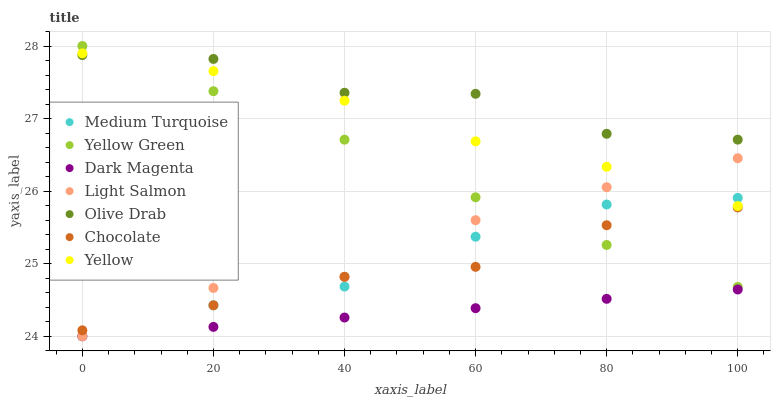Does Dark Magenta have the minimum area under the curve?
Answer yes or no. Yes. Does Olive Drab have the maximum area under the curve?
Answer yes or no. Yes. Does Yellow Green have the minimum area under the curve?
Answer yes or no. No. Does Yellow Green have the maximum area under the curve?
Answer yes or no. No. Is Dark Magenta the smoothest?
Answer yes or no. Yes. Is Olive Drab the roughest?
Answer yes or no. Yes. Is Yellow Green the smoothest?
Answer yes or no. No. Is Yellow Green the roughest?
Answer yes or no. No. Does Light Salmon have the lowest value?
Answer yes or no. Yes. Does Yellow Green have the lowest value?
Answer yes or no. No. Does Yellow Green have the highest value?
Answer yes or no. Yes. Does Yellow have the highest value?
Answer yes or no. No. Is Light Salmon less than Olive Drab?
Answer yes or no. Yes. Is Yellow Green greater than Dark Magenta?
Answer yes or no. Yes. Does Medium Turquoise intersect Light Salmon?
Answer yes or no. Yes. Is Medium Turquoise less than Light Salmon?
Answer yes or no. No. Is Medium Turquoise greater than Light Salmon?
Answer yes or no. No. Does Light Salmon intersect Olive Drab?
Answer yes or no. No. 